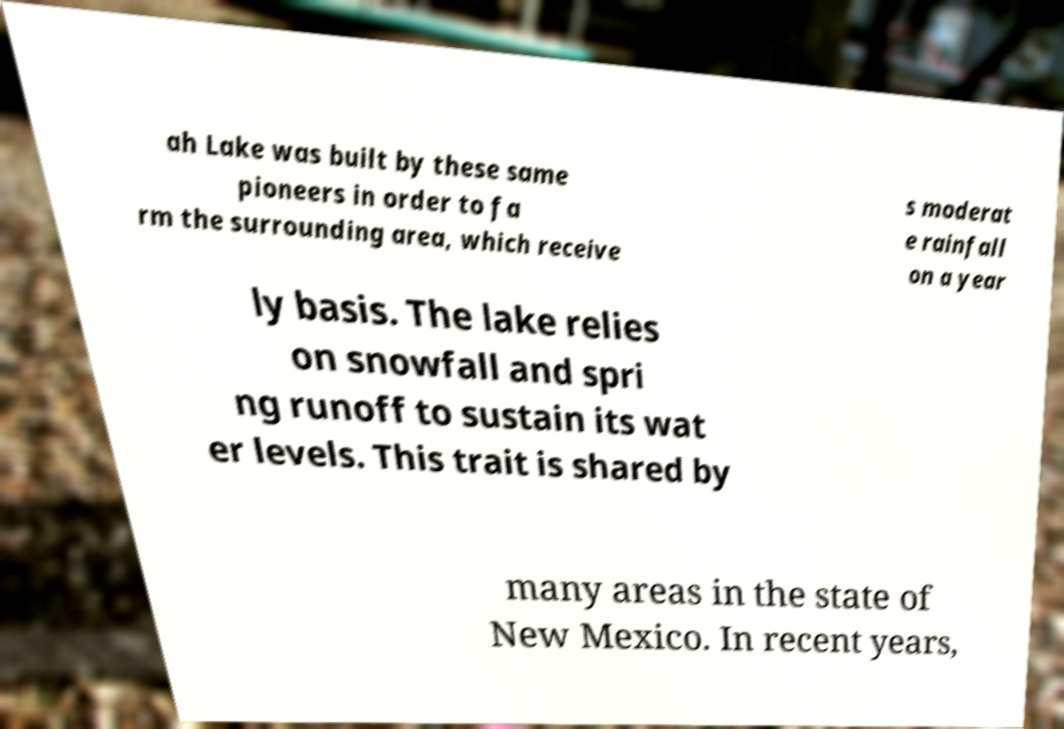For documentation purposes, I need the text within this image transcribed. Could you provide that? ah Lake was built by these same pioneers in order to fa rm the surrounding area, which receive s moderat e rainfall on a year ly basis. The lake relies on snowfall and spri ng runoff to sustain its wat er levels. This trait is shared by many areas in the state of New Mexico. In recent years, 